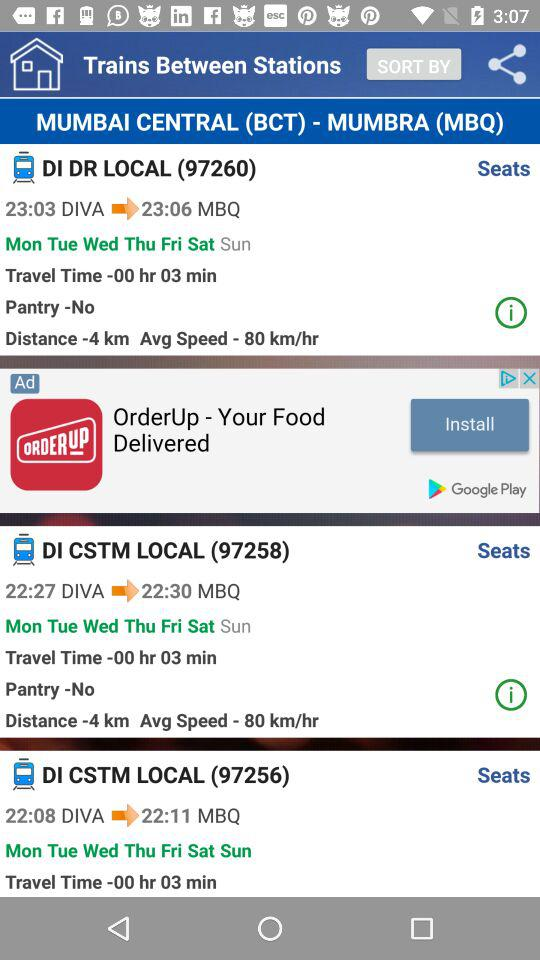What is the departure station? The departure station is Mumbai Central. 